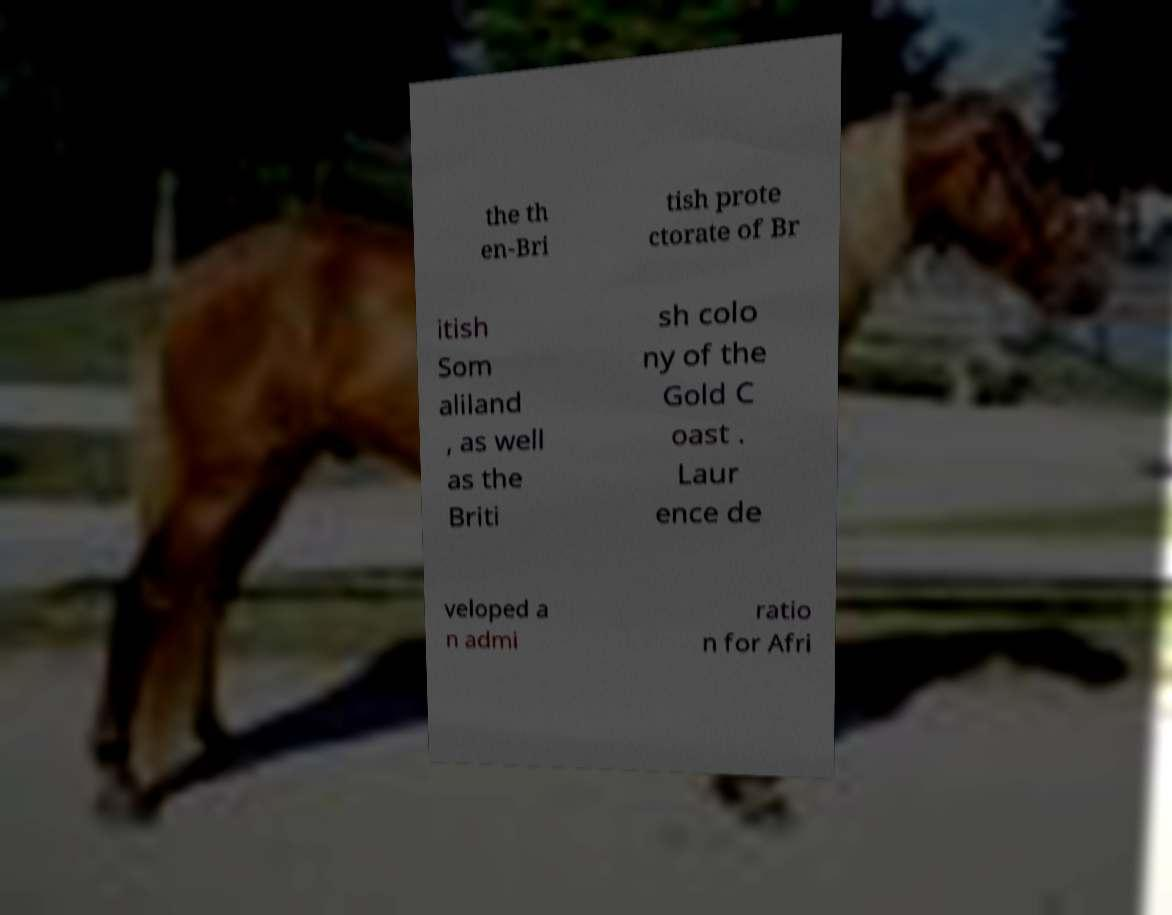Can you accurately transcribe the text from the provided image for me? the th en-Bri tish prote ctorate of Br itish Som aliland , as well as the Briti sh colo ny of the Gold C oast . Laur ence de veloped a n admi ratio n for Afri 